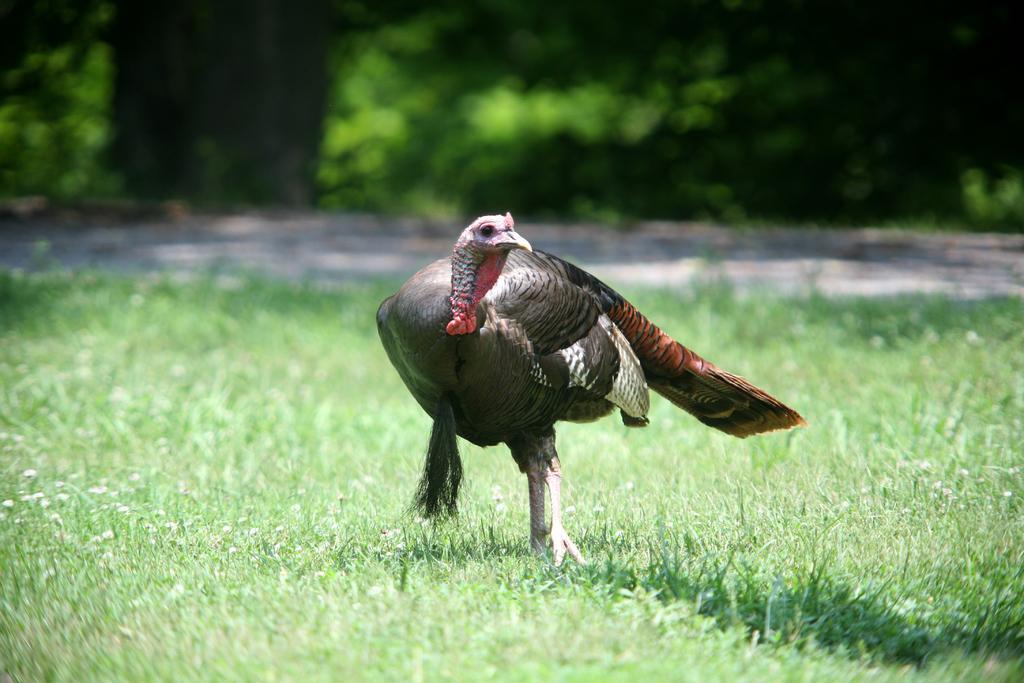How would you summarize this image in a sentence or two? In this image we can see a wild turkey on the ground. In the background there are trees. 